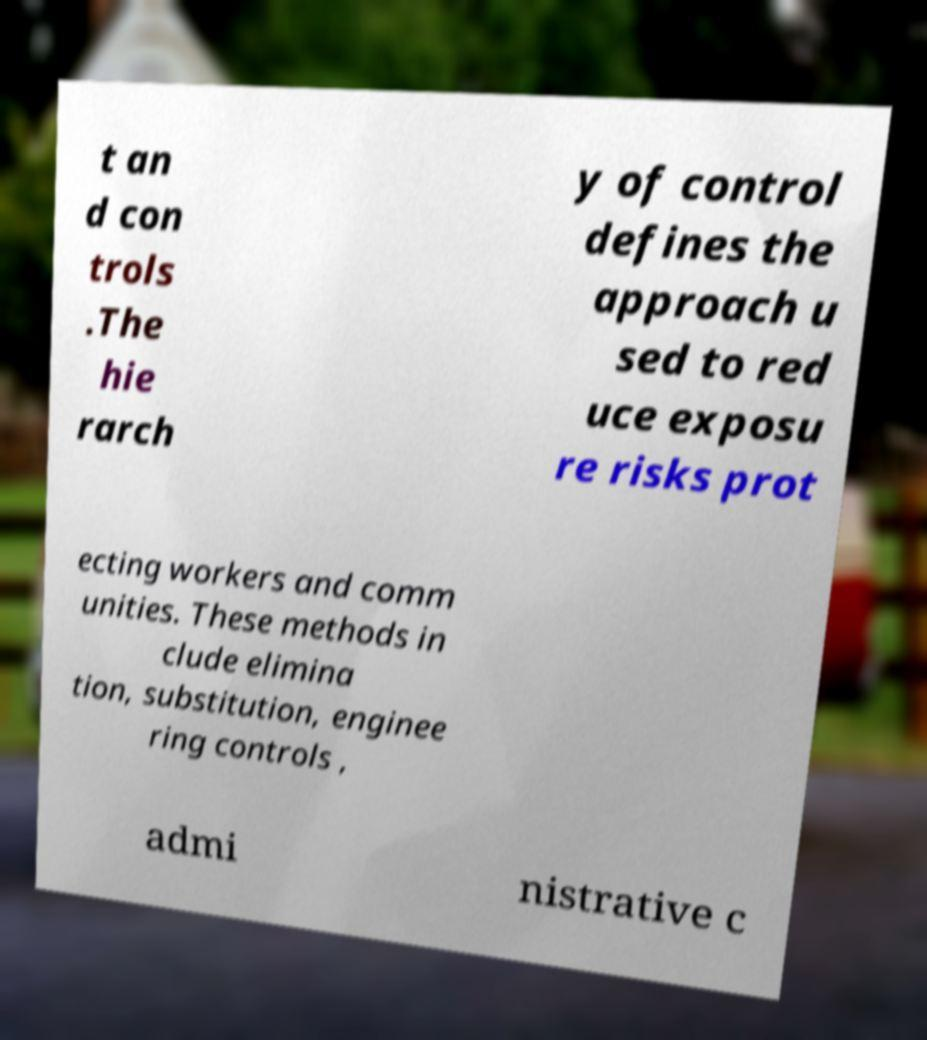Could you assist in decoding the text presented in this image and type it out clearly? t an d con trols .The hie rarch y of control defines the approach u sed to red uce exposu re risks prot ecting workers and comm unities. These methods in clude elimina tion, substitution, enginee ring controls , admi nistrative c 